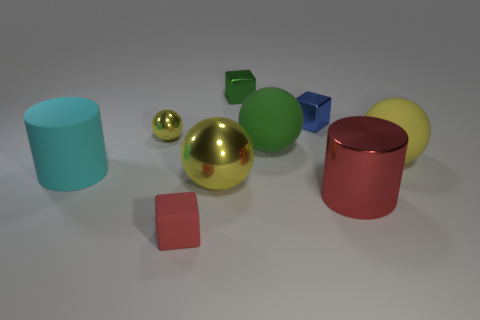Subtract all yellow spheres. How many were subtracted if there are1yellow spheres left? 2 Subtract all red blocks. How many blocks are left? 2 Subtract all green cylinders. How many yellow spheres are left? 3 Subtract all cyan cylinders. How many cylinders are left? 1 Subtract 1 cubes. How many cubes are left? 2 Subtract all cylinders. How many objects are left? 7 Subtract all purple blocks. Subtract all purple spheres. How many blocks are left? 3 Subtract all cyan rubber cylinders. Subtract all cyan cylinders. How many objects are left? 7 Add 3 small yellow metal balls. How many small yellow metal balls are left? 4 Add 8 big purple metal blocks. How many big purple metal blocks exist? 8 